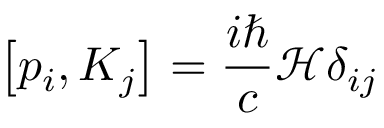<formula> <loc_0><loc_0><loc_500><loc_500>\left [ p _ { i } , K _ { j } \right ] = { \frac { i } { c } } { \mathcal { H } } \delta _ { i j }</formula> 